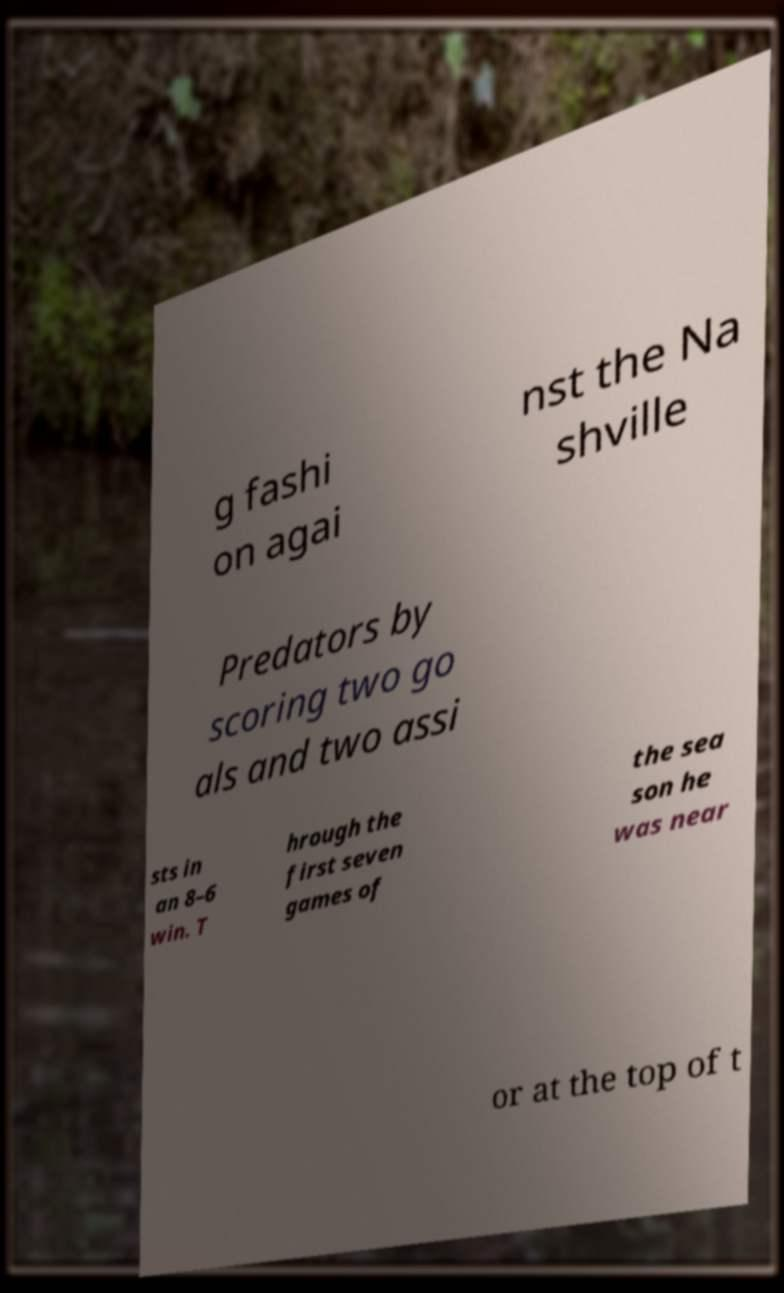There's text embedded in this image that I need extracted. Can you transcribe it verbatim? g fashi on agai nst the Na shville Predators by scoring two go als and two assi sts in an 8–6 win. T hrough the first seven games of the sea son he was near or at the top of t 